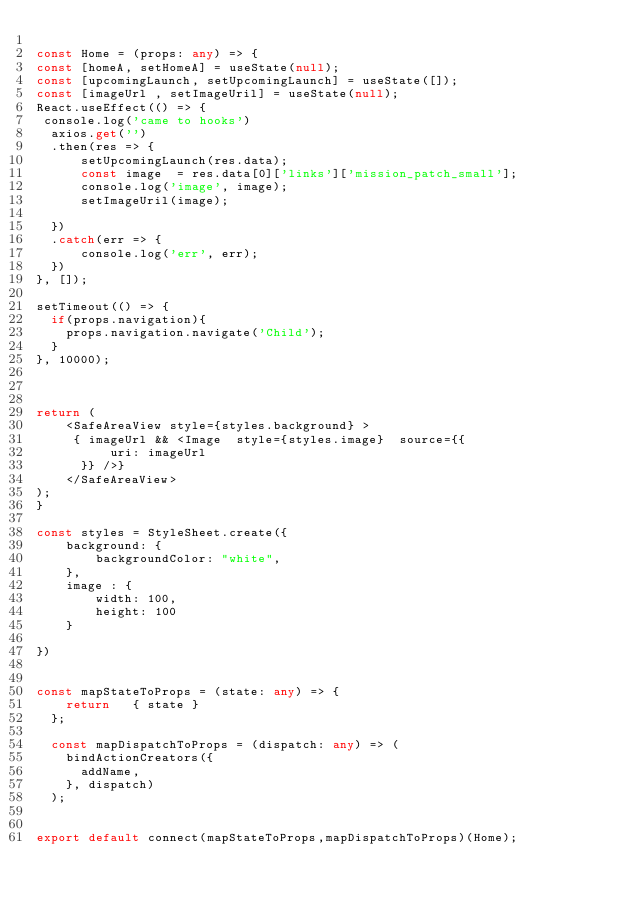<code> <loc_0><loc_0><loc_500><loc_500><_TypeScript_>
const Home = (props: any) => {
const [homeA, setHomeA] = useState(null);
const [upcomingLaunch, setUpcomingLaunch] = useState([]);
const [imageUrl , setImageUril] = useState(null);
React.useEffect(() => {
 console.log('came to hooks')
  axios.get('')
  .then(res => {
      setUpcomingLaunch(res.data);
      const image  = res.data[0]['links']['mission_patch_small'];
      console.log('image', image);
      setImageUril(image);
      
  })
  .catch(err => {
      console.log('err', err);
  })  
}, []);

setTimeout(() => {
  if(props.navigation){
    props.navigation.navigate('Child');
  }
}, 10000);



return (
    <SafeAreaView style={styles.background} >
     { imageUrl && <Image  style={styles.image}  source={{
          uri: imageUrl
      }} />}
    </SafeAreaView>
);
}

const styles = StyleSheet.create({
    background: {
        backgroundColor: "white",
    },
    image : {
        width: 100,
        height: 100
    }

})


const mapStateToProps = (state: any) => {
    return   { state }
  };

  const mapDispatchToProps = (dispatch: any) => (
    bindActionCreators({
      addName,
    }, dispatch)
  );
  

export default connect(mapStateToProps,mapDispatchToProps)(Home);

</code> 